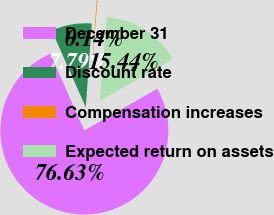<chart> <loc_0><loc_0><loc_500><loc_500><pie_chart><fcel>December 31<fcel>Discount rate<fcel>Compensation increases<fcel>Expected return on assets<nl><fcel>76.63%<fcel>7.79%<fcel>0.14%<fcel>15.44%<nl></chart> 